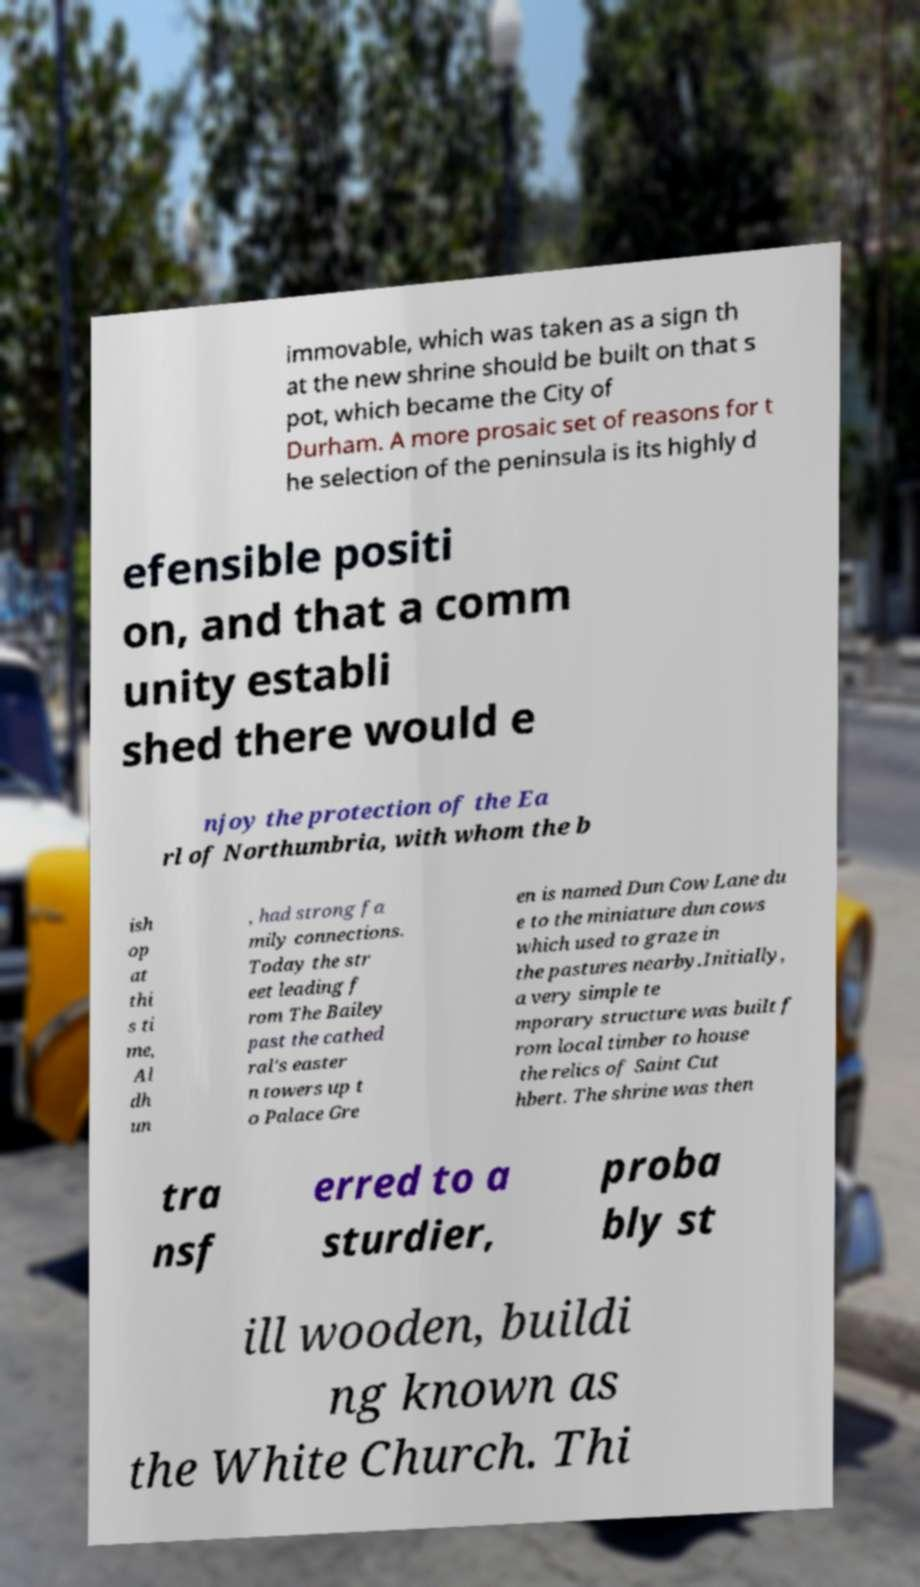Could you extract and type out the text from this image? immovable, which was taken as a sign th at the new shrine should be built on that s pot, which became the City of Durham. A more prosaic set of reasons for t he selection of the peninsula is its highly d efensible positi on, and that a comm unity establi shed there would e njoy the protection of the Ea rl of Northumbria, with whom the b ish op at thi s ti me, Al dh un , had strong fa mily connections. Today the str eet leading f rom The Bailey past the cathed ral's easter n towers up t o Palace Gre en is named Dun Cow Lane du e to the miniature dun cows which used to graze in the pastures nearby.Initially, a very simple te mporary structure was built f rom local timber to house the relics of Saint Cut hbert. The shrine was then tra nsf erred to a sturdier, proba bly st ill wooden, buildi ng known as the White Church. Thi 